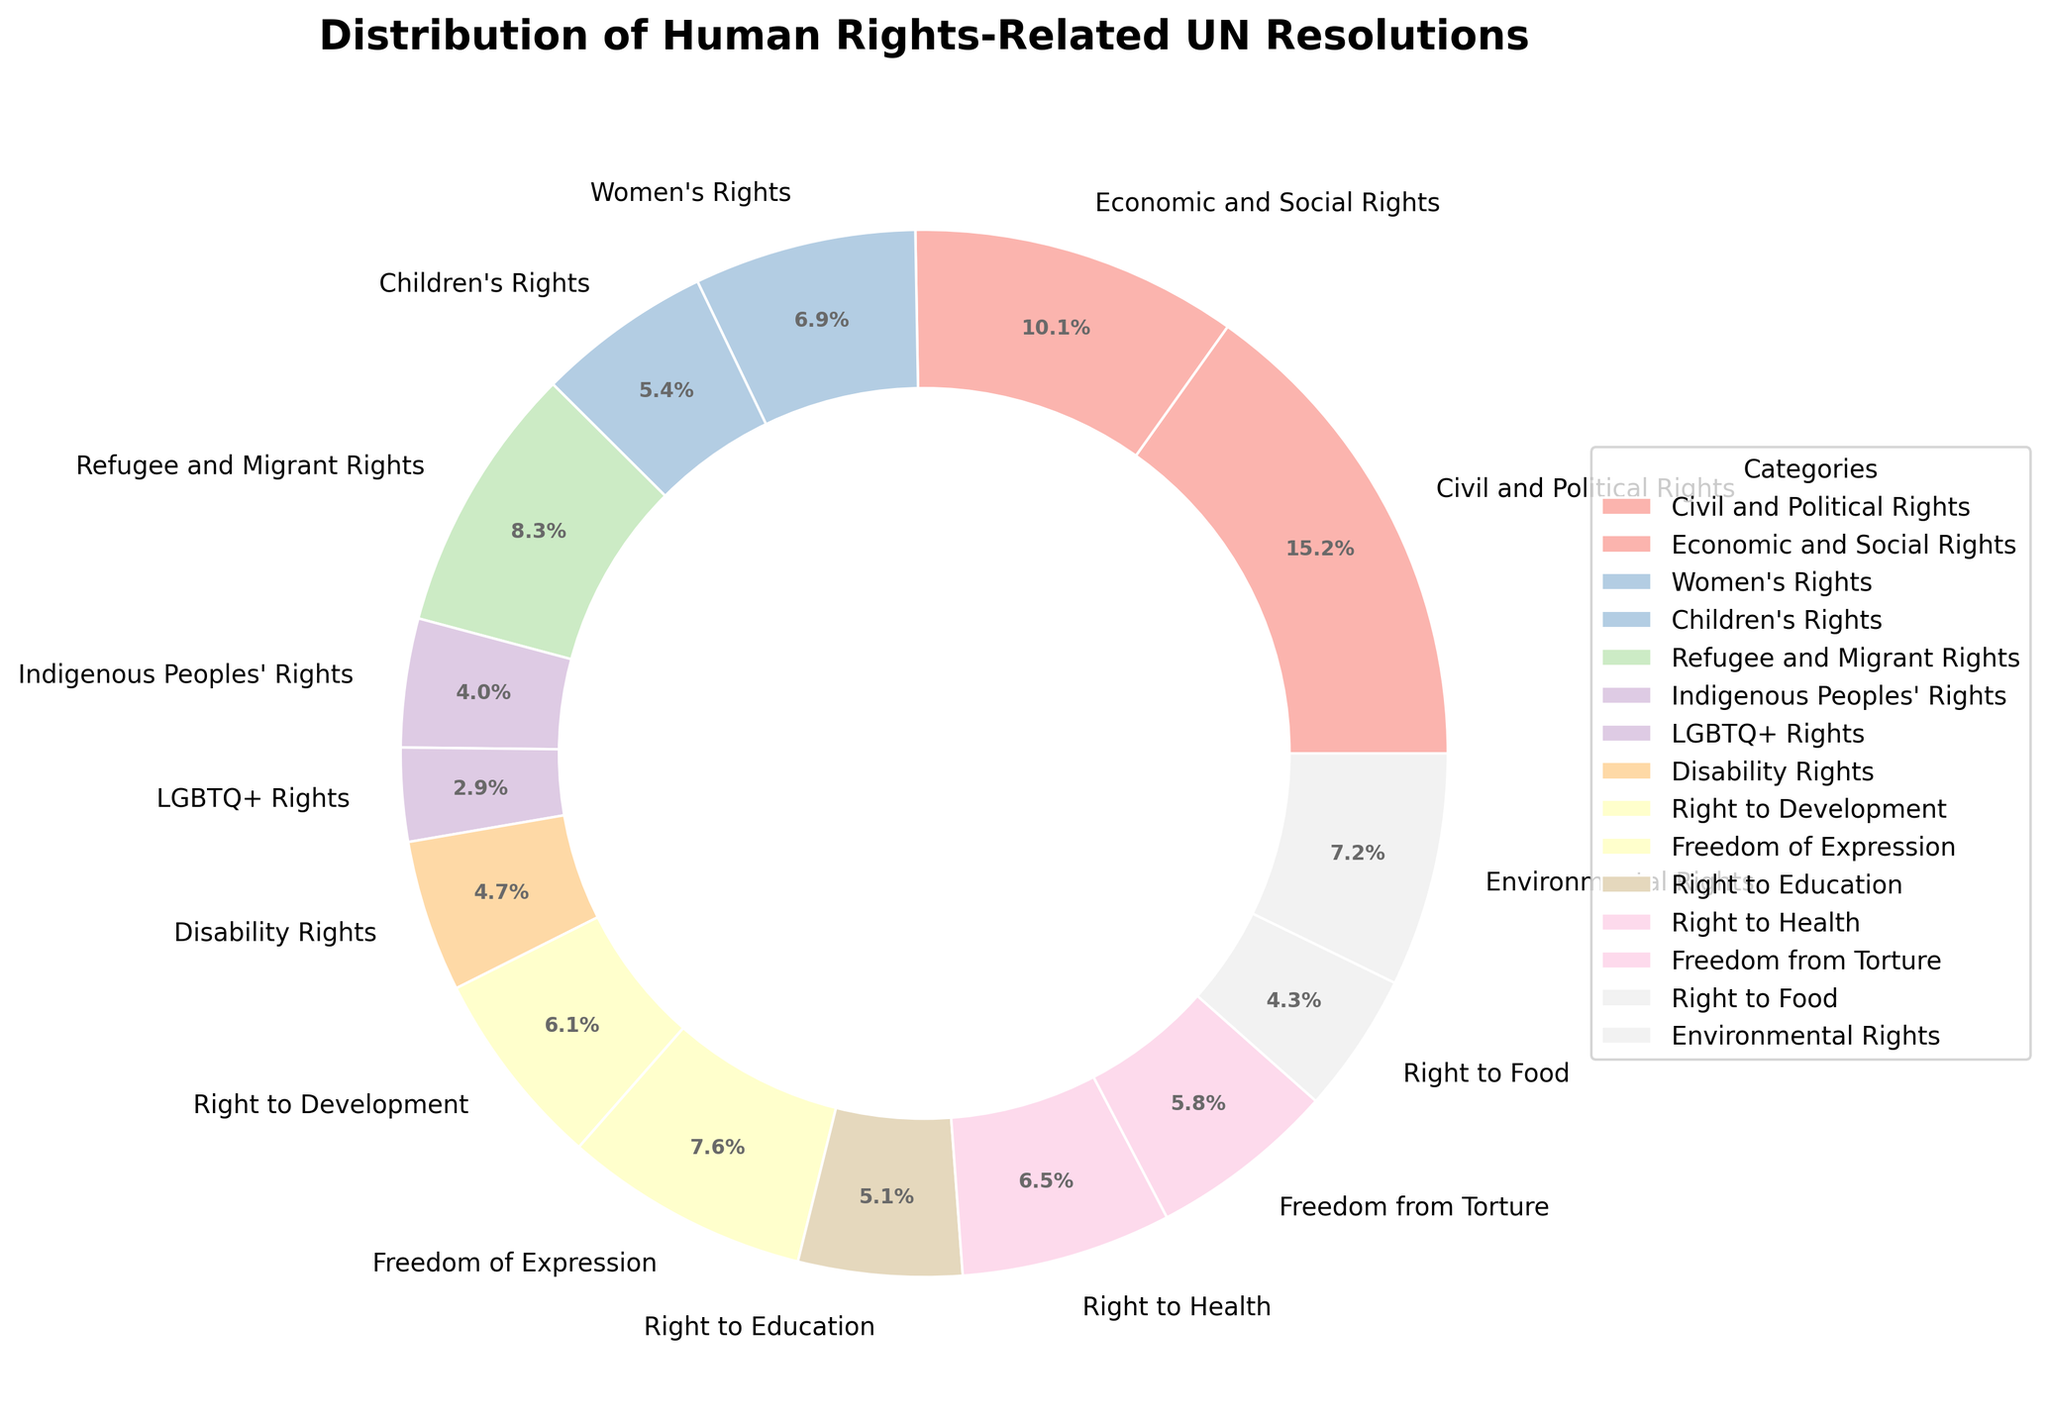What percentage of resolutions are related to Civil and Political Rights? Look at the pie chart and find the section labeled "Civil and Political Rights". The percentage will be shown next to this label.
Answer: 25.3% How many more resolutions address Refugee and Migrant Rights compared to Disability Rights? Find the numbers of resolutions for both categories: "Refugee and Migrant Rights" has 23, while "Disability Rights" has 13. Subtract the smaller number from the larger one: 23 - 13 = 10
Answer: 10 Which category has the least number of resolutions, and what is its percentage share? Identify the smallest section of the pie chart, which is labeled "LGBTQ+ Rights" with 8 resolutions. The percentage can be found next to this label.
Answer: LGBTQ+ Rights, 4.8% Does the sum of resolutions related to Children's Rights and Right to Health exceed those related to Civil and Political Rights? Sum the numbers of resolutions for "Children's Rights" (15) and "Right to Health" (18) to get 33. Compare this to the resolutions for "Civil and Political Rights" which is 42. Since 33 < 42, it does not exceed.
Answer: No Which category has a higher number of resolutions, Environmental Rights or Freedom from Torture? Compare the slice sizes and their labels. "Environmental Rights" has 20 resolutions, while "Freedom from Torture" has 16 resolutions.
Answer: Environmental Rights What is the combined percentage of resolutions addressing Women's Rights and Right to Development? Find the percentages of "Women's Rights" and "Right to Development" from the pie chart. They are 11.4% and 10.2% respectively. Add them together: 11.4% + 10.2% = 21.6%.
Answer: 21.6% Are there more resolutions focused on the Right to Education or the Right to Food? Compare the two categories on the pie chart. "Right to Education" has 14 resolutions, while "Right to Food" has 12.
Answer: Right to Education What is the percentage difference between Economic and Social Rights and Women's Rights? Find the percentages for "Economic and Social Rights" (16.9%) and "Women's Rights" (11.4%). Subtract the smaller from the larger: 16.9% - 11.4% = 5.5%.
Answer: 5.5% How many resolutions in total address Civil and Political Rights, Freedom of Expression, and Freedom from Torture? Add the numbers of resolutions from these categories: Civil and Political Rights (42), Freedom of Expression (21), and Freedom from Torture (16). 42 + 21 + 16 = 79.
Answer: 79 